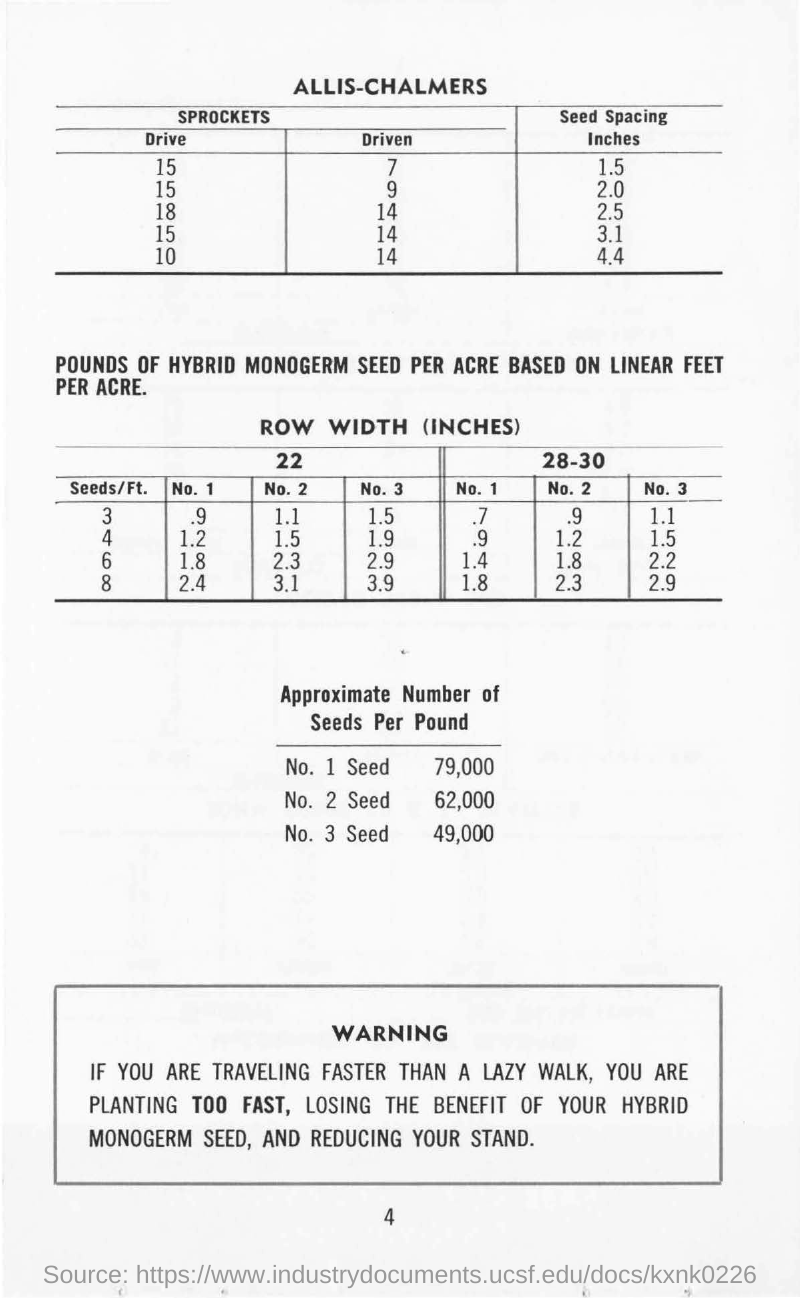What is the first table heading ?
Your response must be concise. ALLIS-CHALMERS. What is the second table heading?
Offer a terse response. ROW WIDTH (INCHES). What is the approximate number of  1 Seed per pound ?
Keep it short and to the point. 79,000. What is the approximate number of  2 Seed per pound ?
Give a very brief answer. 62,000. What is the approximate number of  3 Seed per pound ?
Your answer should be compact. 49,000. 